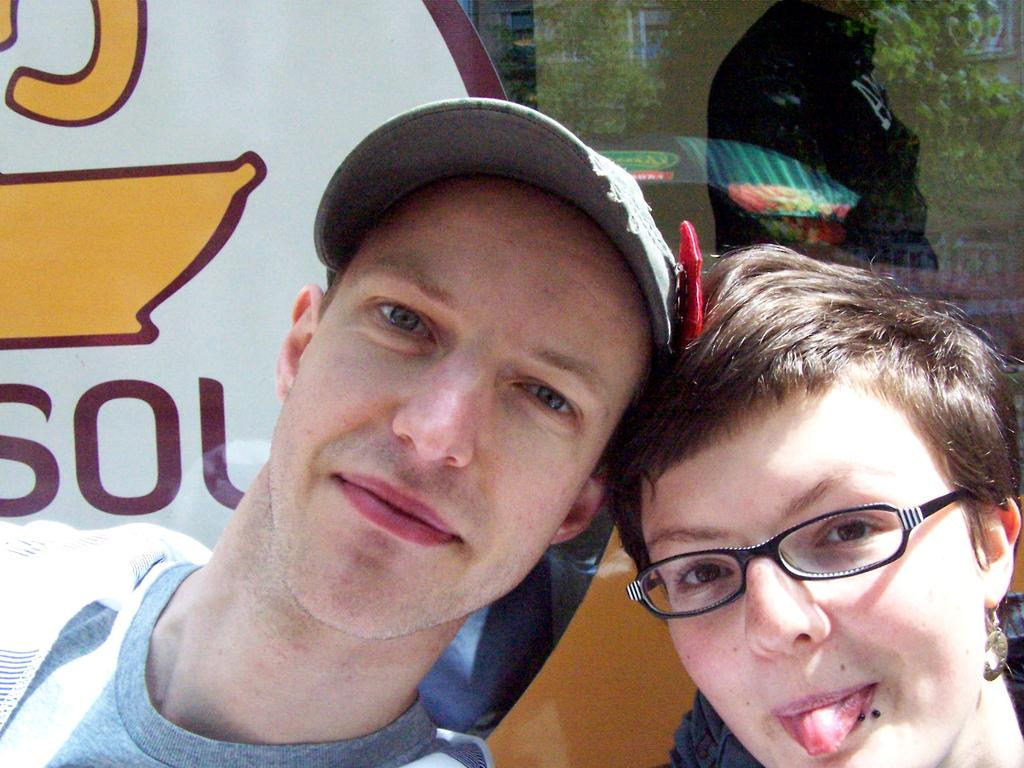How many people are in the image? There are two persons in the image. What is the facial expression of the persons? The persons are smiling. What can be seen in the background of the image? There is a glass wall in the background. Is there any additional information on the glass wall? Yes, there is a poster on the glass wall. What type of milk is being served in the image? There is no milk present in the image. Can you tell me how many airplanes are flying in the background of the image? There are no airplanes visible in the image; it only features two persons and a glass wall with a poster. 